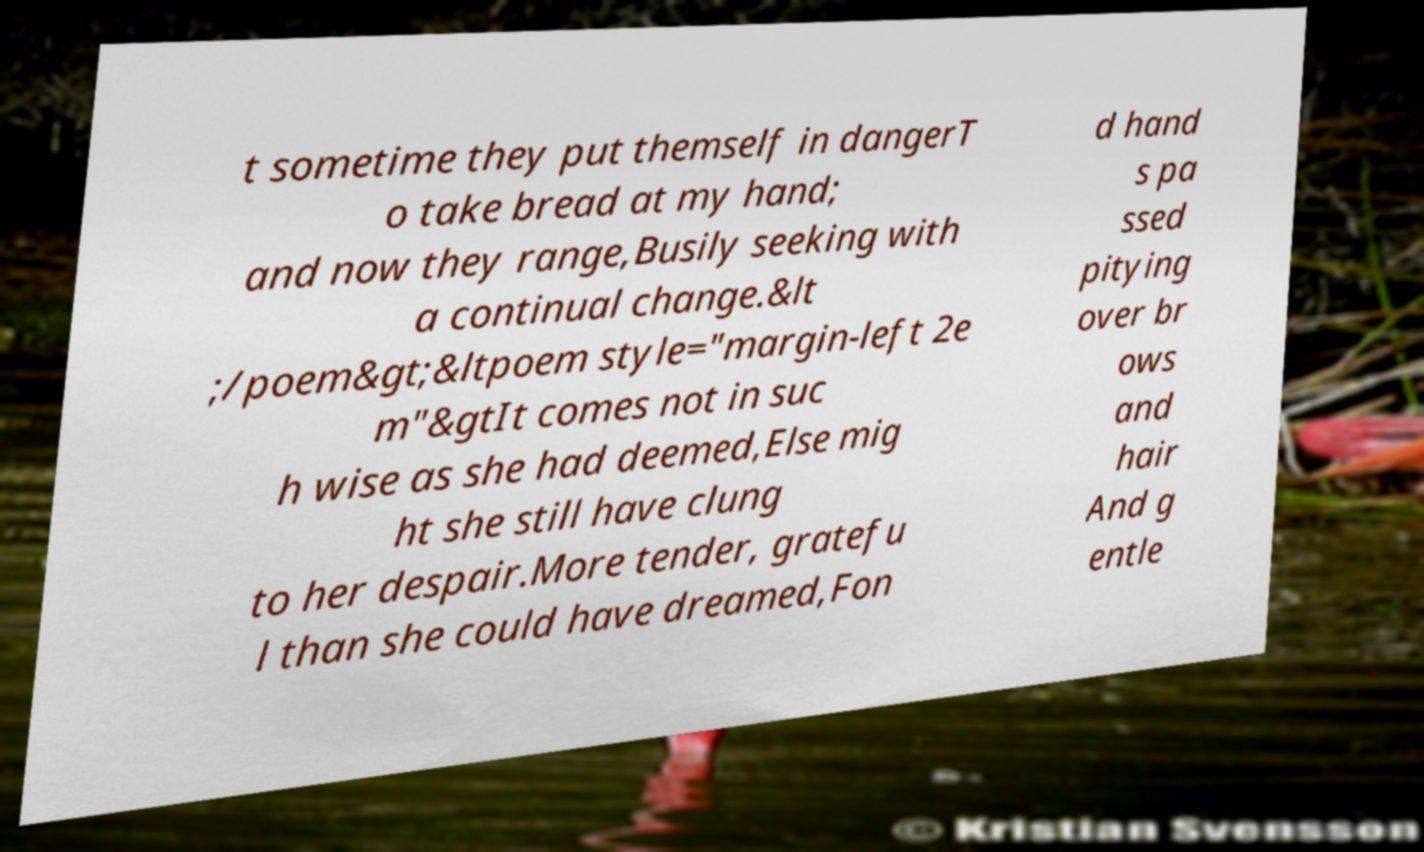I need the written content from this picture converted into text. Can you do that? t sometime they put themself in dangerT o take bread at my hand; and now they range,Busily seeking with a continual change.&lt ;/poem&gt;&ltpoem style="margin-left 2e m"&gtIt comes not in suc h wise as she had deemed,Else mig ht she still have clung to her despair.More tender, gratefu l than she could have dreamed,Fon d hand s pa ssed pitying over br ows and hair And g entle 